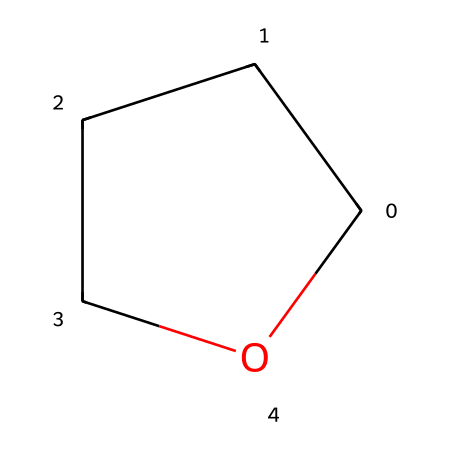what is the molecular formula of this compound? The SMILES notation C1CCCO1 indicates that there are four carbon atoms (C) and eight hydrogen atoms (H), resulting in the molecular formula C4H8O.
Answer: C4H8O how many rings are present in this molecule? The "C1" and "C1" in the SMILES notation indicates a cyclic structure, meaning that there is one ring present in the molecule.
Answer: 1 what type of functional group is present in this molecule? The presence of an oxygen atom (O) between carbon atoms in a cyclic arrangement identifies this molecule as an ether, characterized by the functional group R-O-R.
Answer: ether what is the degree of saturation of the molecule? The degree of saturation can be calculated based on the number of rings and bonds present. Since it is a cyclic compound with single bonds, it has a degree of saturation of 1.
Answer: 1 how does the structure of this ether contribute to its physical properties? The cyclic structure contributes to lower volatility compared to linear ethers due to its stability, making it suitable for synthetic materials in basketball courts as it resists wear and changes in temperature.
Answer: stability what is the prominent property of tetrahydrofuran that makes it useful in synthetic materials? Tetrahydrofuran has excellent solvating properties, which allows it to dissolve a wide variety of polymers, making it useful in creating synthetic materials for basketball courts.
Answer: solvating properties 